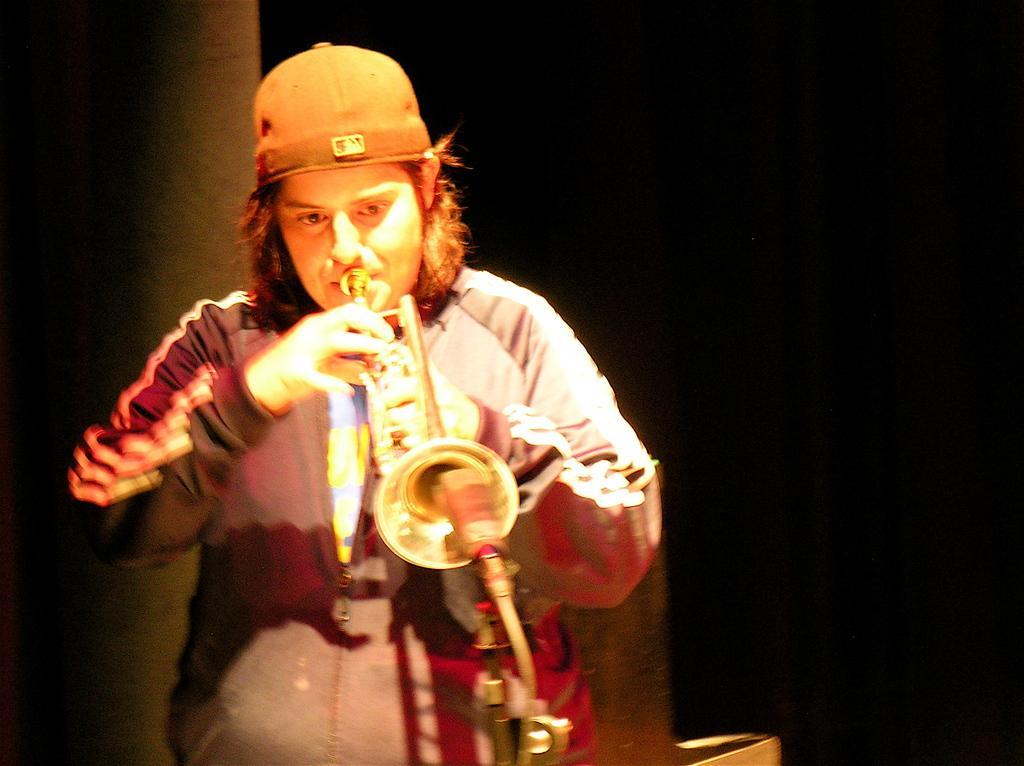Can you describe this image briefly? On the left side, there is a person wearing a cap, playing a musical instrument and standing. And the background is dark in color. 